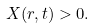<formula> <loc_0><loc_0><loc_500><loc_500>X ( r , t ) > 0 .</formula> 